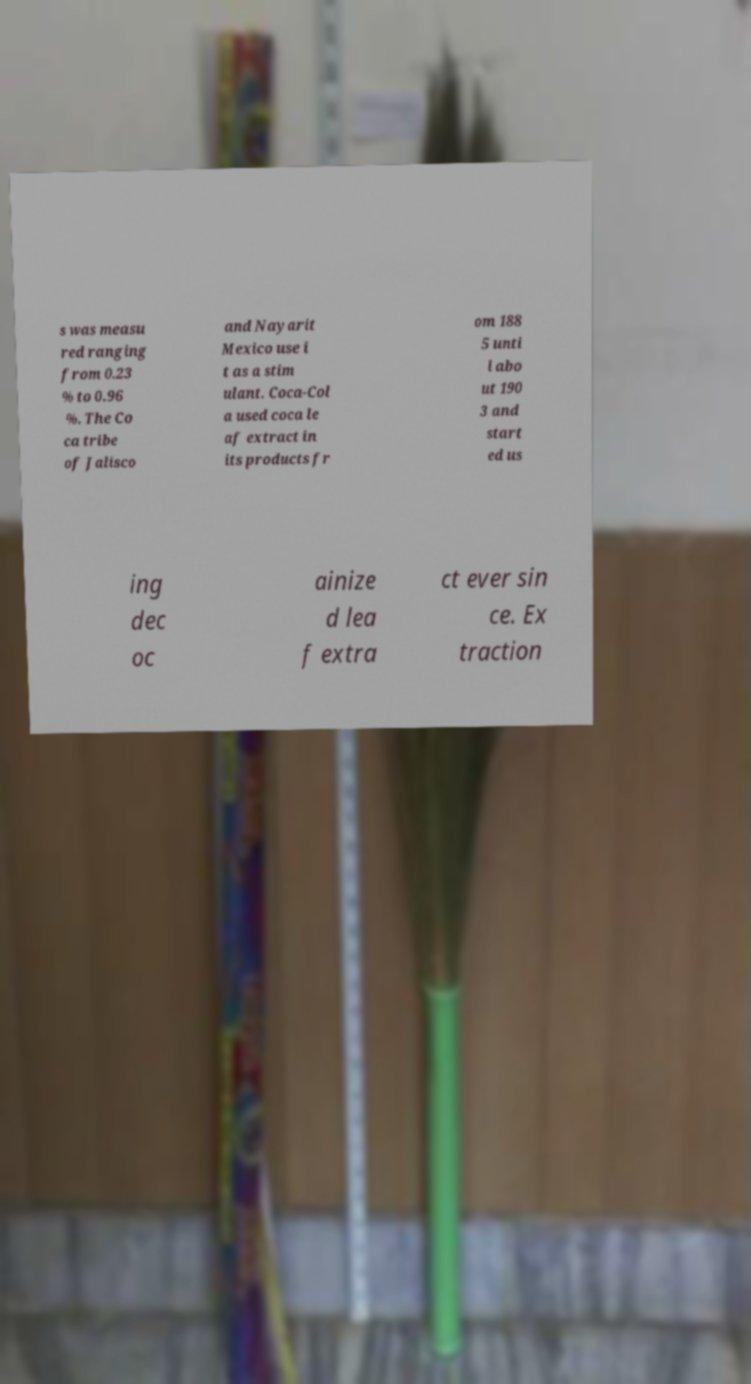There's text embedded in this image that I need extracted. Can you transcribe it verbatim? s was measu red ranging from 0.23 % to 0.96 %. The Co ca tribe of Jalisco and Nayarit Mexico use i t as a stim ulant. Coca-Col a used coca le af extract in its products fr om 188 5 unti l abo ut 190 3 and start ed us ing dec oc ainize d lea f extra ct ever sin ce. Ex traction 